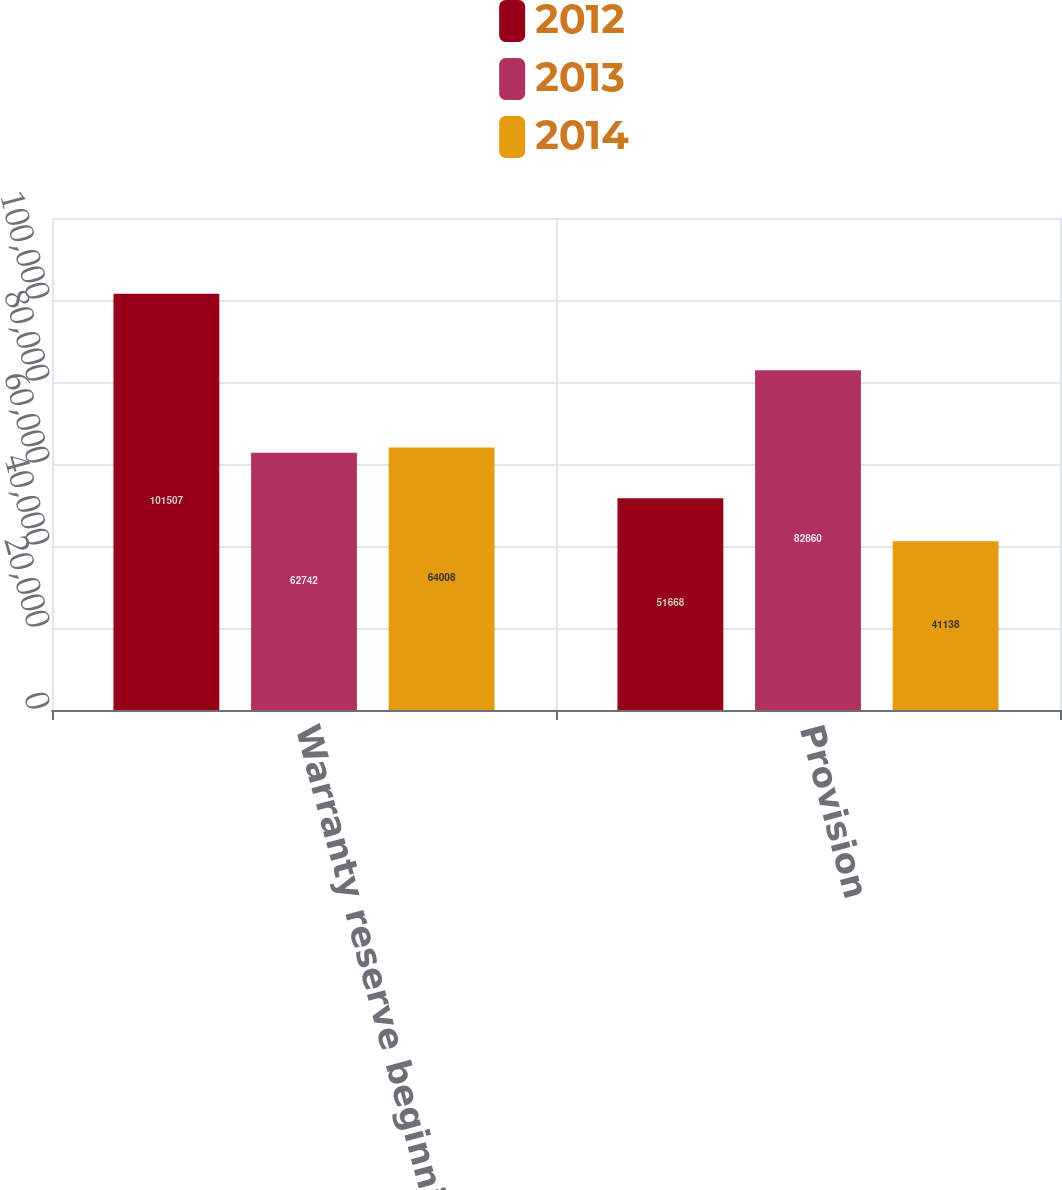Convert chart to OTSL. <chart><loc_0><loc_0><loc_500><loc_500><stacked_bar_chart><ecel><fcel>Warranty reserve beginning of<fcel>Provision<nl><fcel>2012<fcel>101507<fcel>51668<nl><fcel>2013<fcel>62742<fcel>82860<nl><fcel>2014<fcel>64008<fcel>41138<nl></chart> 